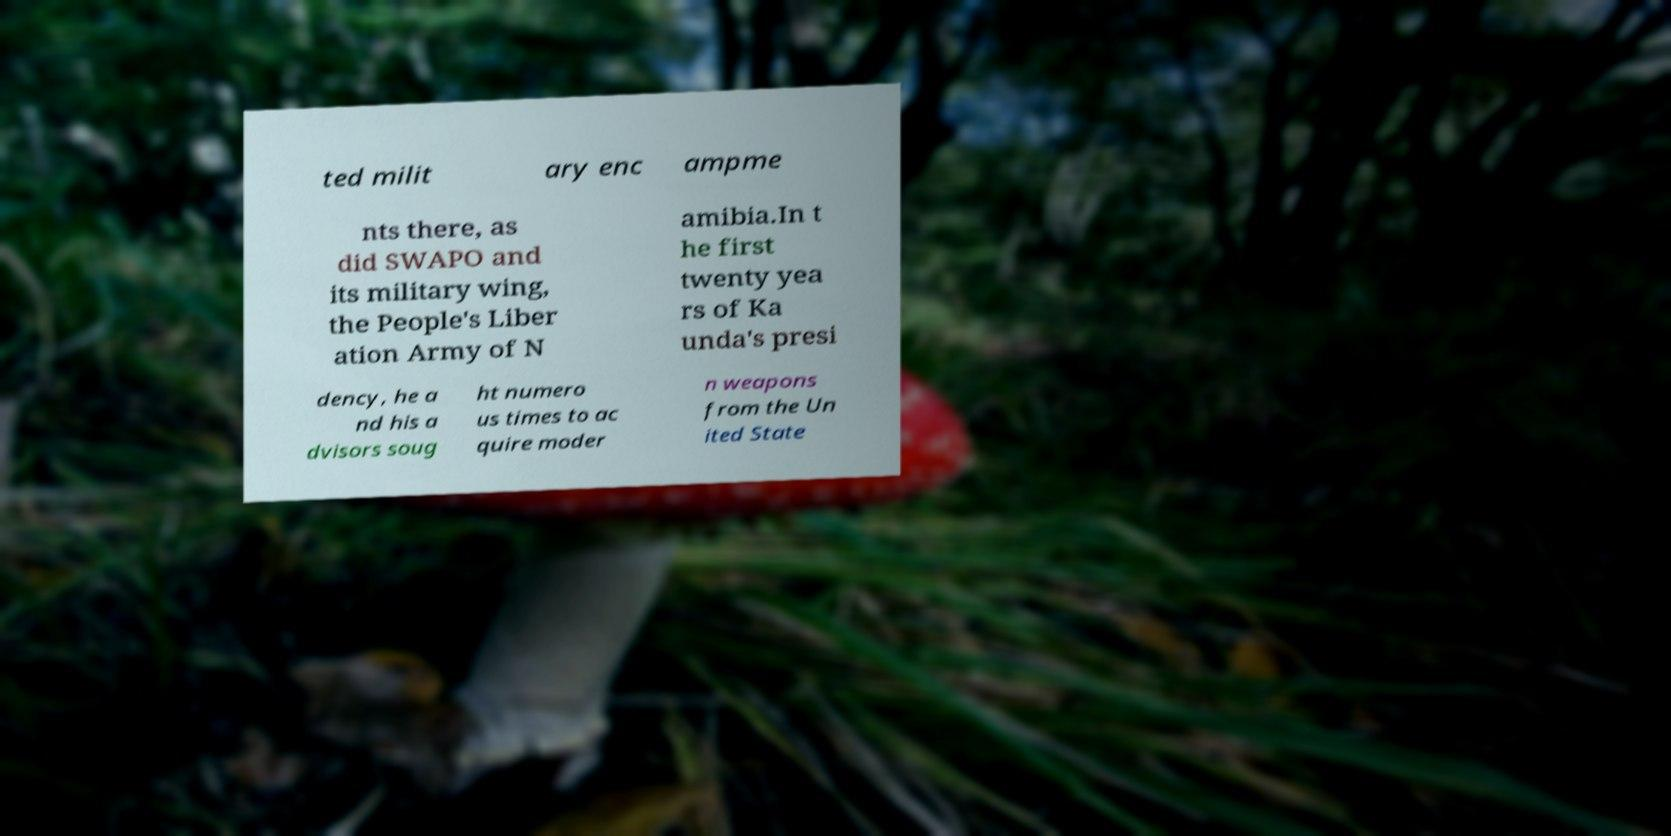Could you assist in decoding the text presented in this image and type it out clearly? ted milit ary enc ampme nts there, as did SWAPO and its military wing, the People's Liber ation Army of N amibia.In t he first twenty yea rs of Ka unda's presi dency, he a nd his a dvisors soug ht numero us times to ac quire moder n weapons from the Un ited State 